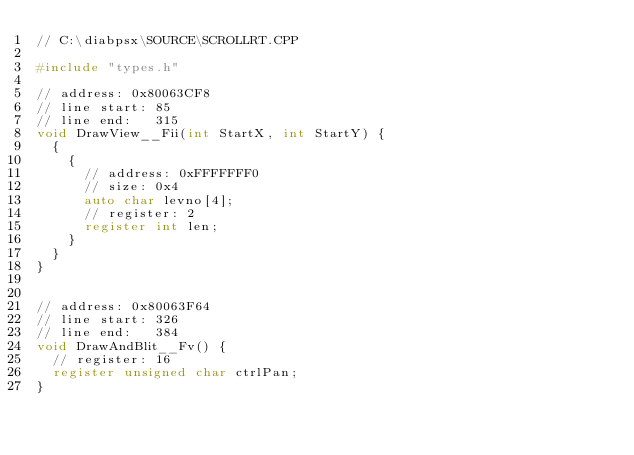Convert code to text. <code><loc_0><loc_0><loc_500><loc_500><_C++_>// C:\diabpsx\SOURCE\SCROLLRT.CPP

#include "types.h"

// address: 0x80063CF8
// line start: 85
// line end:   315
void DrawView__Fii(int StartX, int StartY) {
	{
		{
			// address: 0xFFFFFFF0
			// size: 0x4
			auto char levno[4];
			// register: 2
			register int len;
		}
	}
}


// address: 0x80063F64
// line start: 326
// line end:   384
void DrawAndBlit__Fv() {
	// register: 16
	register unsigned char ctrlPan;
}


</code> 